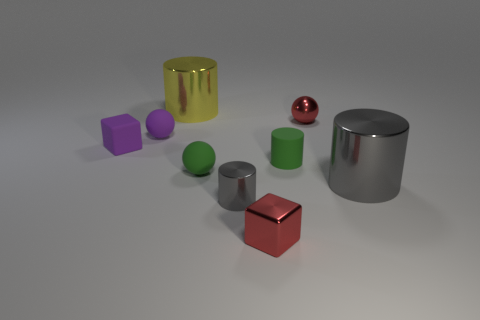Subtract all yellow cylinders. How many cylinders are left? 3 Subtract all small rubber spheres. How many spheres are left? 1 Subtract all purple cylinders. Subtract all blue blocks. How many cylinders are left? 4 Add 1 large purple spheres. How many objects exist? 10 Subtract all balls. How many objects are left? 6 Add 2 yellow cylinders. How many yellow cylinders are left? 3 Add 7 small red cubes. How many small red cubes exist? 8 Subtract 0 blue spheres. How many objects are left? 9 Subtract all small gray balls. Subtract all small green objects. How many objects are left? 7 